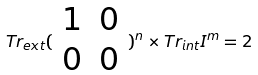Convert formula to latex. <formula><loc_0><loc_0><loc_500><loc_500>T r _ { e x t } ( \begin{array} { c c } 1 & 0 \\ 0 & 0 \end{array} ) ^ { n } \times T r _ { i n t } I ^ { m } = 2</formula> 